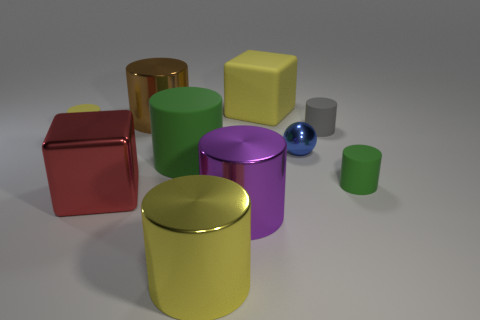How many green cylinders must be subtracted to get 1 green cylinders? 1 Subtract all big green cylinders. How many cylinders are left? 6 Subtract all gray cylinders. How many cylinders are left? 6 Subtract 4 cylinders. How many cylinders are left? 3 Subtract all red cylinders. Subtract all red blocks. How many cylinders are left? 7 Subtract all cubes. How many objects are left? 8 Add 2 cyan metallic things. How many cyan metallic things exist? 2 Subtract 1 yellow cylinders. How many objects are left? 9 Subtract all big brown metal objects. Subtract all big purple cylinders. How many objects are left? 8 Add 2 large yellow objects. How many large yellow objects are left? 4 